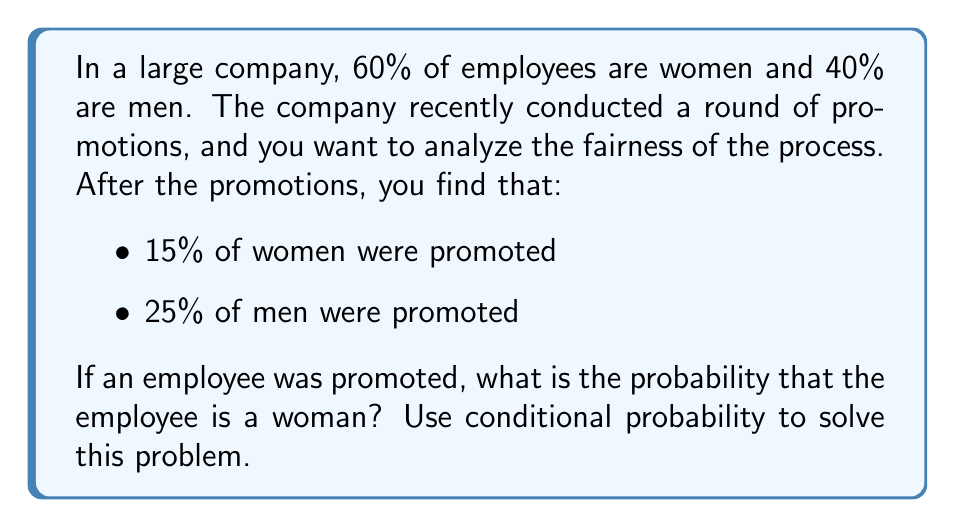Help me with this question. Let's approach this step-by-step using conditional probability:

1) First, let's define our events:
   W: Employee is a woman
   M: Employee is a man
   P: Employee was promoted

2) We're given the following probabilities:
   $P(W) = 0.60$
   $P(M) = 0.40$
   $P(P|W) = 0.15$ (probability of promotion given the employee is a woman)
   $P(P|M) = 0.25$ (probability of promotion given the employee is a man)

3) We want to find $P(W|P)$ (probability that an employee is a woman, given they were promoted)

4) We can use Bayes' Theorem:

   $$P(W|P) = \frac{P(P|W) \cdot P(W)}{P(P)}$$

5) We know $P(P|W)$ and $P(W)$, but we need to calculate $P(P)$

6) We can calculate $P(P)$ using the law of total probability:

   $$P(P) = P(P|W) \cdot P(W) + P(P|M) \cdot P(M)$$

7) Let's substitute the values:

   $$P(P) = 0.15 \cdot 0.60 + 0.25 \cdot 0.40 = 0.09 + 0.10 = 0.19$$

8) Now we have all the components to use Bayes' Theorem:

   $$P(W|P) = \frac{0.15 \cdot 0.60}{0.19} = \frac{0.09}{0.19} \approx 0.4737$$
Answer: The probability that a promoted employee is a woman is approximately 0.4737 or 47.37%. 